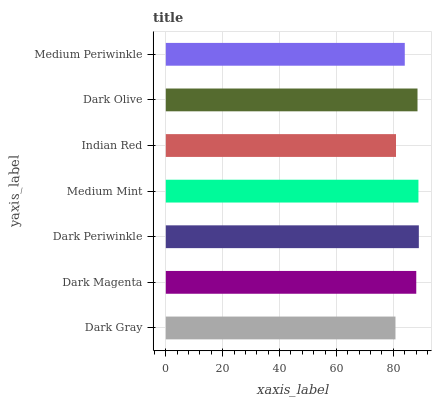Is Dark Gray the minimum?
Answer yes or no. Yes. Is Dark Periwinkle the maximum?
Answer yes or no. Yes. Is Dark Magenta the minimum?
Answer yes or no. No. Is Dark Magenta the maximum?
Answer yes or no. No. Is Dark Magenta greater than Dark Gray?
Answer yes or no. Yes. Is Dark Gray less than Dark Magenta?
Answer yes or no. Yes. Is Dark Gray greater than Dark Magenta?
Answer yes or no. No. Is Dark Magenta less than Dark Gray?
Answer yes or no. No. Is Dark Magenta the high median?
Answer yes or no. Yes. Is Dark Magenta the low median?
Answer yes or no. Yes. Is Indian Red the high median?
Answer yes or no. No. Is Dark Periwinkle the low median?
Answer yes or no. No. 